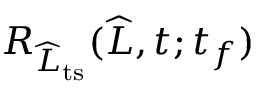Convert formula to latex. <formula><loc_0><loc_0><loc_500><loc_500>R _ { \widehat { L } _ { t s } } ( \widehat { L } , t ; t _ { f } )</formula> 